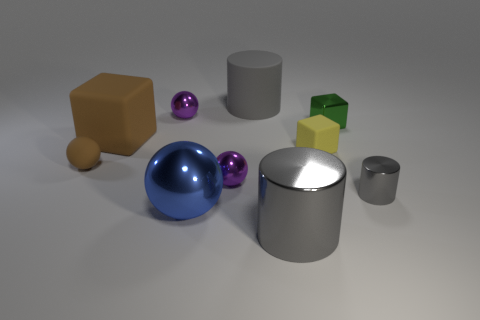What is the material of the large cylinder that is to the right of the rubber cylinder?
Make the answer very short. Metal. There is a big object in front of the big sphere; how many tiny brown balls are left of it?
Give a very brief answer. 1. Is there a big brown matte thing of the same shape as the gray matte object?
Ensure brevity in your answer.  No. Do the purple shiny object that is left of the big metallic ball and the purple shiny ball that is in front of the shiny block have the same size?
Offer a terse response. Yes. What is the shape of the purple thing in front of the small rubber object that is right of the large gray shiny cylinder?
Your answer should be very brief. Sphere. How many cyan rubber cylinders have the same size as the yellow thing?
Offer a very short reply. 0. Are any small green metallic cubes visible?
Your answer should be compact. Yes. Is there anything else that is the same color as the small metallic cube?
Your answer should be very brief. No. There is a large blue object that is made of the same material as the small gray thing; what shape is it?
Your answer should be compact. Sphere. There is a big cylinder in front of the rubber object to the right of the large gray cylinder that is behind the small green metal thing; what color is it?
Offer a terse response. Gray. 